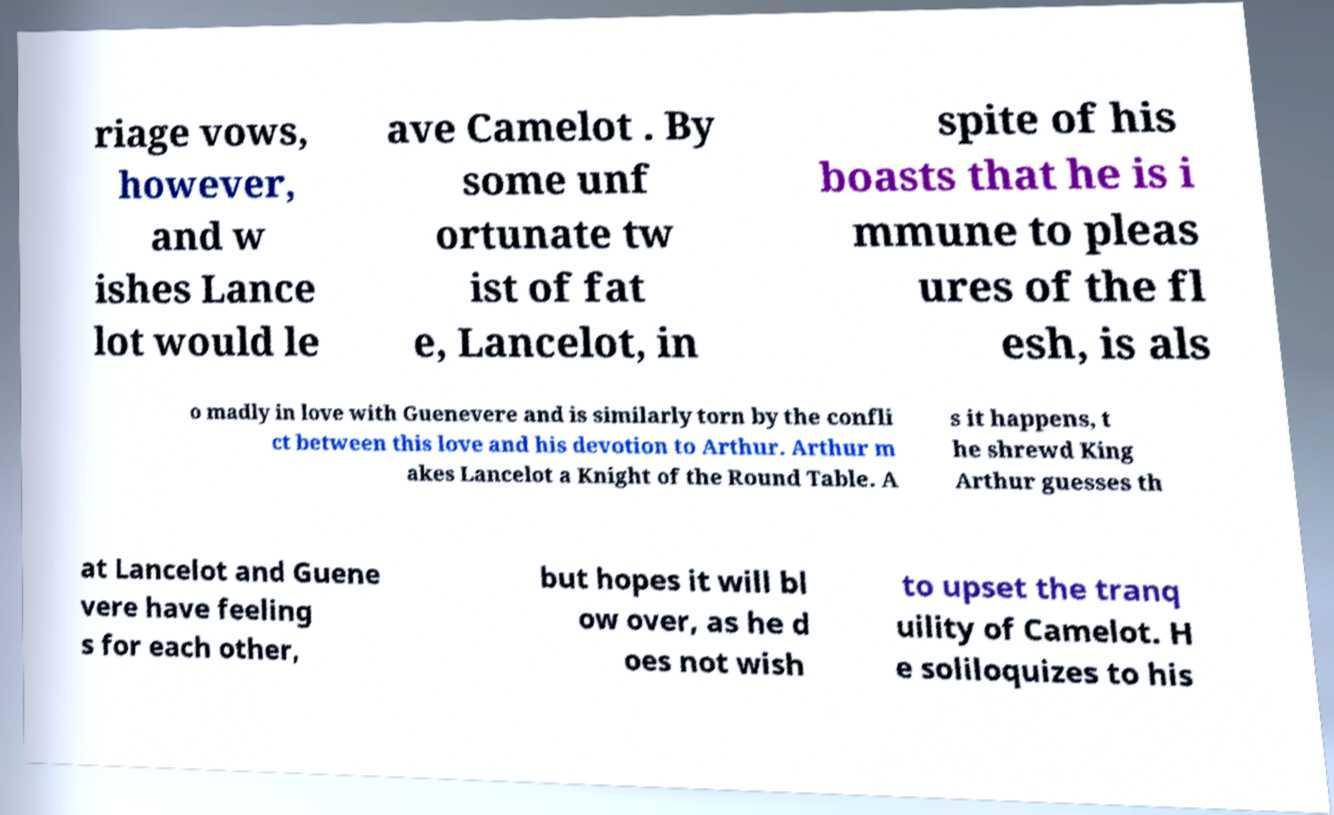Can you read and provide the text displayed in the image?This photo seems to have some interesting text. Can you extract and type it out for me? riage vows, however, and w ishes Lance lot would le ave Camelot . By some unf ortunate tw ist of fat e, Lancelot, in spite of his boasts that he is i mmune to pleas ures of the fl esh, is als o madly in love with Guenevere and is similarly torn by the confli ct between this love and his devotion to Arthur. Arthur m akes Lancelot a Knight of the Round Table. A s it happens, t he shrewd King Arthur guesses th at Lancelot and Guene vere have feeling s for each other, but hopes it will bl ow over, as he d oes not wish to upset the tranq uility of Camelot. H e soliloquizes to his 